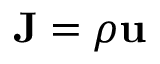<formula> <loc_0><loc_0><loc_500><loc_500>J = \rho u</formula> 